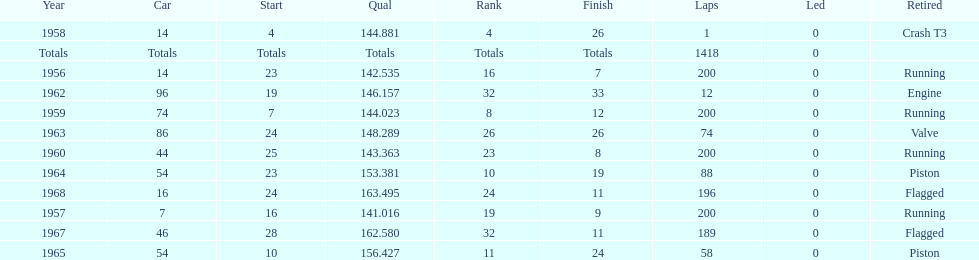For how long did bob veith hold the number 54 car at the indy 500? 2 years. 